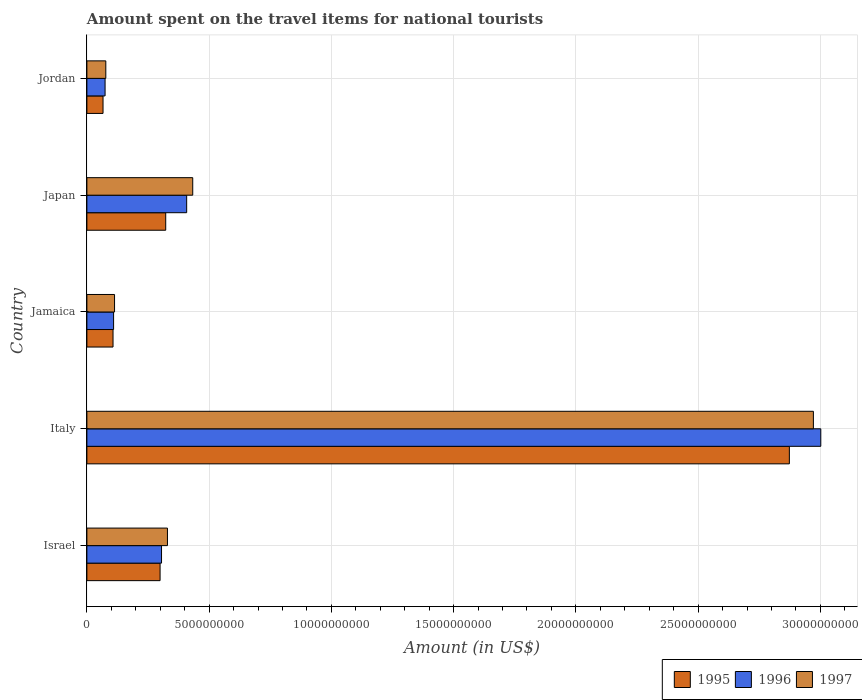How many different coloured bars are there?
Your answer should be very brief. 3. How many groups of bars are there?
Your answer should be compact. 5. Are the number of bars per tick equal to the number of legend labels?
Keep it short and to the point. Yes. Are the number of bars on each tick of the Y-axis equal?
Your answer should be very brief. Yes. How many bars are there on the 4th tick from the top?
Your answer should be very brief. 3. In how many cases, is the number of bars for a given country not equal to the number of legend labels?
Your answer should be very brief. 0. What is the amount spent on the travel items for national tourists in 1995 in Japan?
Provide a short and direct response. 3.22e+09. Across all countries, what is the maximum amount spent on the travel items for national tourists in 1995?
Offer a very short reply. 2.87e+1. Across all countries, what is the minimum amount spent on the travel items for national tourists in 1997?
Offer a very short reply. 7.74e+08. In which country was the amount spent on the travel items for national tourists in 1996 minimum?
Offer a very short reply. Jordan. What is the total amount spent on the travel items for national tourists in 1997 in the graph?
Ensure brevity in your answer.  3.92e+1. What is the difference between the amount spent on the travel items for national tourists in 1996 in Israel and that in Italy?
Your answer should be compact. -2.70e+1. What is the difference between the amount spent on the travel items for national tourists in 1997 in Italy and the amount spent on the travel items for national tourists in 1995 in Japan?
Your answer should be very brief. 2.65e+1. What is the average amount spent on the travel items for national tourists in 1997 per country?
Provide a succinct answer. 7.85e+09. What is the difference between the amount spent on the travel items for national tourists in 1997 and amount spent on the travel items for national tourists in 1996 in Japan?
Your answer should be compact. 2.48e+08. What is the ratio of the amount spent on the travel items for national tourists in 1996 in Jamaica to that in Japan?
Make the answer very short. 0.27. Is the difference between the amount spent on the travel items for national tourists in 1997 in Italy and Japan greater than the difference between the amount spent on the travel items for national tourists in 1996 in Italy and Japan?
Your answer should be compact. No. What is the difference between the highest and the second highest amount spent on the travel items for national tourists in 1995?
Ensure brevity in your answer.  2.55e+1. What is the difference between the highest and the lowest amount spent on the travel items for national tourists in 1996?
Offer a very short reply. 2.93e+1. In how many countries, is the amount spent on the travel items for national tourists in 1995 greater than the average amount spent on the travel items for national tourists in 1995 taken over all countries?
Make the answer very short. 1. Is the sum of the amount spent on the travel items for national tourists in 1996 in Israel and Jordan greater than the maximum amount spent on the travel items for national tourists in 1995 across all countries?
Give a very brief answer. No. What does the 1st bar from the top in Jamaica represents?
Your answer should be compact. 1997. How many bars are there?
Provide a succinct answer. 15. Are all the bars in the graph horizontal?
Offer a very short reply. Yes. How many countries are there in the graph?
Ensure brevity in your answer.  5. Does the graph contain any zero values?
Keep it short and to the point. No. Does the graph contain grids?
Your response must be concise. Yes. How are the legend labels stacked?
Your response must be concise. Horizontal. What is the title of the graph?
Offer a very short reply. Amount spent on the travel items for national tourists. Does "2006" appear as one of the legend labels in the graph?
Ensure brevity in your answer.  No. What is the label or title of the Y-axis?
Provide a short and direct response. Country. What is the Amount (in US$) in 1995 in Israel?
Your answer should be very brief. 2.99e+09. What is the Amount (in US$) of 1996 in Israel?
Ensure brevity in your answer.  3.05e+09. What is the Amount (in US$) in 1997 in Israel?
Ensure brevity in your answer.  3.30e+09. What is the Amount (in US$) in 1995 in Italy?
Ensure brevity in your answer.  2.87e+1. What is the Amount (in US$) of 1996 in Italy?
Provide a short and direct response. 3.00e+1. What is the Amount (in US$) in 1997 in Italy?
Keep it short and to the point. 2.97e+1. What is the Amount (in US$) of 1995 in Jamaica?
Your response must be concise. 1.07e+09. What is the Amount (in US$) in 1996 in Jamaica?
Provide a succinct answer. 1.09e+09. What is the Amount (in US$) in 1997 in Jamaica?
Keep it short and to the point. 1.13e+09. What is the Amount (in US$) in 1995 in Japan?
Your answer should be very brief. 3.22e+09. What is the Amount (in US$) of 1996 in Japan?
Make the answer very short. 4.08e+09. What is the Amount (in US$) in 1997 in Japan?
Make the answer very short. 4.33e+09. What is the Amount (in US$) of 1995 in Jordan?
Ensure brevity in your answer.  6.60e+08. What is the Amount (in US$) in 1996 in Jordan?
Your answer should be compact. 7.44e+08. What is the Amount (in US$) of 1997 in Jordan?
Your answer should be very brief. 7.74e+08. Across all countries, what is the maximum Amount (in US$) of 1995?
Your response must be concise. 2.87e+1. Across all countries, what is the maximum Amount (in US$) in 1996?
Provide a short and direct response. 3.00e+1. Across all countries, what is the maximum Amount (in US$) of 1997?
Your answer should be very brief. 2.97e+1. Across all countries, what is the minimum Amount (in US$) of 1995?
Provide a succinct answer. 6.60e+08. Across all countries, what is the minimum Amount (in US$) of 1996?
Your answer should be very brief. 7.44e+08. Across all countries, what is the minimum Amount (in US$) in 1997?
Offer a terse response. 7.74e+08. What is the total Amount (in US$) of 1995 in the graph?
Offer a terse response. 3.67e+1. What is the total Amount (in US$) of 1996 in the graph?
Your answer should be very brief. 3.90e+1. What is the total Amount (in US$) in 1997 in the graph?
Ensure brevity in your answer.  3.92e+1. What is the difference between the Amount (in US$) of 1995 in Israel and that in Italy?
Make the answer very short. -2.57e+1. What is the difference between the Amount (in US$) of 1996 in Israel and that in Italy?
Your answer should be compact. -2.70e+1. What is the difference between the Amount (in US$) of 1997 in Israel and that in Italy?
Offer a very short reply. -2.64e+1. What is the difference between the Amount (in US$) of 1995 in Israel and that in Jamaica?
Your answer should be very brief. 1.92e+09. What is the difference between the Amount (in US$) of 1996 in Israel and that in Jamaica?
Offer a very short reply. 1.96e+09. What is the difference between the Amount (in US$) of 1997 in Israel and that in Jamaica?
Ensure brevity in your answer.  2.16e+09. What is the difference between the Amount (in US$) of 1995 in Israel and that in Japan?
Offer a very short reply. -2.31e+08. What is the difference between the Amount (in US$) in 1996 in Israel and that in Japan?
Provide a short and direct response. -1.03e+09. What is the difference between the Amount (in US$) of 1997 in Israel and that in Japan?
Keep it short and to the point. -1.03e+09. What is the difference between the Amount (in US$) of 1995 in Israel and that in Jordan?
Keep it short and to the point. 2.33e+09. What is the difference between the Amount (in US$) in 1996 in Israel and that in Jordan?
Ensure brevity in your answer.  2.31e+09. What is the difference between the Amount (in US$) in 1997 in Israel and that in Jordan?
Your answer should be very brief. 2.52e+09. What is the difference between the Amount (in US$) in 1995 in Italy and that in Jamaica?
Give a very brief answer. 2.77e+1. What is the difference between the Amount (in US$) in 1996 in Italy and that in Jamaica?
Ensure brevity in your answer.  2.89e+1. What is the difference between the Amount (in US$) in 1997 in Italy and that in Jamaica?
Provide a succinct answer. 2.86e+1. What is the difference between the Amount (in US$) of 1995 in Italy and that in Japan?
Keep it short and to the point. 2.55e+1. What is the difference between the Amount (in US$) in 1996 in Italy and that in Japan?
Provide a succinct answer. 2.59e+1. What is the difference between the Amount (in US$) of 1997 in Italy and that in Japan?
Your answer should be compact. 2.54e+1. What is the difference between the Amount (in US$) in 1995 in Italy and that in Jordan?
Ensure brevity in your answer.  2.81e+1. What is the difference between the Amount (in US$) in 1996 in Italy and that in Jordan?
Make the answer very short. 2.93e+1. What is the difference between the Amount (in US$) of 1997 in Italy and that in Jordan?
Your answer should be compact. 2.89e+1. What is the difference between the Amount (in US$) in 1995 in Jamaica and that in Japan?
Give a very brief answer. -2.16e+09. What is the difference between the Amount (in US$) in 1996 in Jamaica and that in Japan?
Offer a very short reply. -2.99e+09. What is the difference between the Amount (in US$) in 1997 in Jamaica and that in Japan?
Give a very brief answer. -3.20e+09. What is the difference between the Amount (in US$) of 1995 in Jamaica and that in Jordan?
Make the answer very short. 4.09e+08. What is the difference between the Amount (in US$) of 1996 in Jamaica and that in Jordan?
Provide a short and direct response. 3.48e+08. What is the difference between the Amount (in US$) of 1997 in Jamaica and that in Jordan?
Give a very brief answer. 3.57e+08. What is the difference between the Amount (in US$) of 1995 in Japan and that in Jordan?
Make the answer very short. 2.56e+09. What is the difference between the Amount (in US$) of 1996 in Japan and that in Jordan?
Offer a very short reply. 3.34e+09. What is the difference between the Amount (in US$) of 1997 in Japan and that in Jordan?
Your answer should be very brief. 3.56e+09. What is the difference between the Amount (in US$) of 1995 in Israel and the Amount (in US$) of 1996 in Italy?
Make the answer very short. -2.70e+1. What is the difference between the Amount (in US$) of 1995 in Israel and the Amount (in US$) of 1997 in Italy?
Provide a succinct answer. -2.67e+1. What is the difference between the Amount (in US$) of 1996 in Israel and the Amount (in US$) of 1997 in Italy?
Make the answer very short. -2.67e+1. What is the difference between the Amount (in US$) of 1995 in Israel and the Amount (in US$) of 1996 in Jamaica?
Ensure brevity in your answer.  1.90e+09. What is the difference between the Amount (in US$) in 1995 in Israel and the Amount (in US$) in 1997 in Jamaica?
Keep it short and to the point. 1.86e+09. What is the difference between the Amount (in US$) in 1996 in Israel and the Amount (in US$) in 1997 in Jamaica?
Your answer should be very brief. 1.92e+09. What is the difference between the Amount (in US$) of 1995 in Israel and the Amount (in US$) of 1996 in Japan?
Your answer should be compact. -1.09e+09. What is the difference between the Amount (in US$) in 1995 in Israel and the Amount (in US$) in 1997 in Japan?
Your answer should be very brief. -1.34e+09. What is the difference between the Amount (in US$) of 1996 in Israel and the Amount (in US$) of 1997 in Japan?
Give a very brief answer. -1.28e+09. What is the difference between the Amount (in US$) in 1995 in Israel and the Amount (in US$) in 1996 in Jordan?
Give a very brief answer. 2.25e+09. What is the difference between the Amount (in US$) of 1995 in Israel and the Amount (in US$) of 1997 in Jordan?
Your response must be concise. 2.22e+09. What is the difference between the Amount (in US$) of 1996 in Israel and the Amount (in US$) of 1997 in Jordan?
Your response must be concise. 2.28e+09. What is the difference between the Amount (in US$) of 1995 in Italy and the Amount (in US$) of 1996 in Jamaica?
Offer a very short reply. 2.76e+1. What is the difference between the Amount (in US$) of 1995 in Italy and the Amount (in US$) of 1997 in Jamaica?
Provide a short and direct response. 2.76e+1. What is the difference between the Amount (in US$) of 1996 in Italy and the Amount (in US$) of 1997 in Jamaica?
Your answer should be very brief. 2.89e+1. What is the difference between the Amount (in US$) of 1995 in Italy and the Amount (in US$) of 1996 in Japan?
Your answer should be compact. 2.46e+1. What is the difference between the Amount (in US$) in 1995 in Italy and the Amount (in US$) in 1997 in Japan?
Your answer should be compact. 2.44e+1. What is the difference between the Amount (in US$) in 1996 in Italy and the Amount (in US$) in 1997 in Japan?
Your answer should be compact. 2.57e+1. What is the difference between the Amount (in US$) in 1995 in Italy and the Amount (in US$) in 1996 in Jordan?
Ensure brevity in your answer.  2.80e+1. What is the difference between the Amount (in US$) in 1995 in Italy and the Amount (in US$) in 1997 in Jordan?
Your answer should be compact. 2.80e+1. What is the difference between the Amount (in US$) in 1996 in Italy and the Amount (in US$) in 1997 in Jordan?
Your answer should be compact. 2.92e+1. What is the difference between the Amount (in US$) in 1995 in Jamaica and the Amount (in US$) in 1996 in Japan?
Your answer should be very brief. -3.01e+09. What is the difference between the Amount (in US$) in 1995 in Jamaica and the Amount (in US$) in 1997 in Japan?
Keep it short and to the point. -3.26e+09. What is the difference between the Amount (in US$) in 1996 in Jamaica and the Amount (in US$) in 1997 in Japan?
Make the answer very short. -3.24e+09. What is the difference between the Amount (in US$) of 1995 in Jamaica and the Amount (in US$) of 1996 in Jordan?
Ensure brevity in your answer.  3.25e+08. What is the difference between the Amount (in US$) of 1995 in Jamaica and the Amount (in US$) of 1997 in Jordan?
Offer a very short reply. 2.95e+08. What is the difference between the Amount (in US$) in 1996 in Jamaica and the Amount (in US$) in 1997 in Jordan?
Ensure brevity in your answer.  3.18e+08. What is the difference between the Amount (in US$) of 1995 in Japan and the Amount (in US$) of 1996 in Jordan?
Provide a short and direct response. 2.48e+09. What is the difference between the Amount (in US$) of 1995 in Japan and the Amount (in US$) of 1997 in Jordan?
Provide a succinct answer. 2.45e+09. What is the difference between the Amount (in US$) in 1996 in Japan and the Amount (in US$) in 1997 in Jordan?
Make the answer very short. 3.31e+09. What is the average Amount (in US$) in 1995 per country?
Offer a very short reply. 7.34e+09. What is the average Amount (in US$) of 1996 per country?
Provide a succinct answer. 7.80e+09. What is the average Amount (in US$) in 1997 per country?
Give a very brief answer. 7.85e+09. What is the difference between the Amount (in US$) in 1995 and Amount (in US$) in 1996 in Israel?
Your response must be concise. -6.00e+07. What is the difference between the Amount (in US$) of 1995 and Amount (in US$) of 1997 in Israel?
Keep it short and to the point. -3.02e+08. What is the difference between the Amount (in US$) of 1996 and Amount (in US$) of 1997 in Israel?
Your answer should be very brief. -2.42e+08. What is the difference between the Amount (in US$) of 1995 and Amount (in US$) of 1996 in Italy?
Your response must be concise. -1.29e+09. What is the difference between the Amount (in US$) of 1995 and Amount (in US$) of 1997 in Italy?
Your response must be concise. -9.83e+08. What is the difference between the Amount (in US$) in 1996 and Amount (in US$) in 1997 in Italy?
Provide a succinct answer. 3.03e+08. What is the difference between the Amount (in US$) in 1995 and Amount (in US$) in 1996 in Jamaica?
Provide a succinct answer. -2.30e+07. What is the difference between the Amount (in US$) in 1995 and Amount (in US$) in 1997 in Jamaica?
Provide a succinct answer. -6.20e+07. What is the difference between the Amount (in US$) of 1996 and Amount (in US$) of 1997 in Jamaica?
Give a very brief answer. -3.90e+07. What is the difference between the Amount (in US$) in 1995 and Amount (in US$) in 1996 in Japan?
Provide a short and direct response. -8.57e+08. What is the difference between the Amount (in US$) of 1995 and Amount (in US$) of 1997 in Japan?
Ensure brevity in your answer.  -1.10e+09. What is the difference between the Amount (in US$) of 1996 and Amount (in US$) of 1997 in Japan?
Ensure brevity in your answer.  -2.48e+08. What is the difference between the Amount (in US$) in 1995 and Amount (in US$) in 1996 in Jordan?
Your answer should be very brief. -8.40e+07. What is the difference between the Amount (in US$) of 1995 and Amount (in US$) of 1997 in Jordan?
Make the answer very short. -1.14e+08. What is the difference between the Amount (in US$) of 1996 and Amount (in US$) of 1997 in Jordan?
Your answer should be very brief. -3.00e+07. What is the ratio of the Amount (in US$) in 1995 in Israel to that in Italy?
Ensure brevity in your answer.  0.1. What is the ratio of the Amount (in US$) of 1996 in Israel to that in Italy?
Give a very brief answer. 0.1. What is the ratio of the Amount (in US$) in 1997 in Israel to that in Italy?
Keep it short and to the point. 0.11. What is the ratio of the Amount (in US$) in 1995 in Israel to that in Jamaica?
Make the answer very short. 2.8. What is the ratio of the Amount (in US$) of 1996 in Israel to that in Jamaica?
Give a very brief answer. 2.8. What is the ratio of the Amount (in US$) in 1997 in Israel to that in Jamaica?
Offer a terse response. 2.91. What is the ratio of the Amount (in US$) of 1995 in Israel to that in Japan?
Keep it short and to the point. 0.93. What is the ratio of the Amount (in US$) in 1996 in Israel to that in Japan?
Offer a very short reply. 0.75. What is the ratio of the Amount (in US$) in 1997 in Israel to that in Japan?
Offer a terse response. 0.76. What is the ratio of the Amount (in US$) in 1995 in Israel to that in Jordan?
Give a very brief answer. 4.53. What is the ratio of the Amount (in US$) in 1996 in Israel to that in Jordan?
Offer a very short reply. 4.1. What is the ratio of the Amount (in US$) in 1997 in Israel to that in Jordan?
Provide a succinct answer. 4.26. What is the ratio of the Amount (in US$) of 1995 in Italy to that in Jamaica?
Your answer should be very brief. 26.88. What is the ratio of the Amount (in US$) in 1996 in Italy to that in Jamaica?
Give a very brief answer. 27.49. What is the ratio of the Amount (in US$) in 1997 in Italy to that in Jamaica?
Offer a very short reply. 26.27. What is the ratio of the Amount (in US$) in 1995 in Italy to that in Japan?
Provide a succinct answer. 8.91. What is the ratio of the Amount (in US$) in 1996 in Italy to that in Japan?
Provide a succinct answer. 7.36. What is the ratio of the Amount (in US$) in 1997 in Italy to that in Japan?
Your answer should be compact. 6.86. What is the ratio of the Amount (in US$) of 1995 in Italy to that in Jordan?
Your answer should be very brief. 43.53. What is the ratio of the Amount (in US$) of 1996 in Italy to that in Jordan?
Give a very brief answer. 40.35. What is the ratio of the Amount (in US$) in 1997 in Italy to that in Jordan?
Your answer should be very brief. 38.39. What is the ratio of the Amount (in US$) of 1995 in Jamaica to that in Japan?
Provide a short and direct response. 0.33. What is the ratio of the Amount (in US$) in 1996 in Jamaica to that in Japan?
Offer a terse response. 0.27. What is the ratio of the Amount (in US$) of 1997 in Jamaica to that in Japan?
Offer a terse response. 0.26. What is the ratio of the Amount (in US$) of 1995 in Jamaica to that in Jordan?
Your answer should be compact. 1.62. What is the ratio of the Amount (in US$) in 1996 in Jamaica to that in Jordan?
Keep it short and to the point. 1.47. What is the ratio of the Amount (in US$) of 1997 in Jamaica to that in Jordan?
Provide a succinct answer. 1.46. What is the ratio of the Amount (in US$) in 1995 in Japan to that in Jordan?
Provide a short and direct response. 4.88. What is the ratio of the Amount (in US$) of 1996 in Japan to that in Jordan?
Offer a very short reply. 5.49. What is the ratio of the Amount (in US$) of 1997 in Japan to that in Jordan?
Provide a short and direct response. 5.59. What is the difference between the highest and the second highest Amount (in US$) in 1995?
Offer a very short reply. 2.55e+1. What is the difference between the highest and the second highest Amount (in US$) of 1996?
Your answer should be very brief. 2.59e+1. What is the difference between the highest and the second highest Amount (in US$) in 1997?
Keep it short and to the point. 2.54e+1. What is the difference between the highest and the lowest Amount (in US$) of 1995?
Offer a terse response. 2.81e+1. What is the difference between the highest and the lowest Amount (in US$) of 1996?
Provide a succinct answer. 2.93e+1. What is the difference between the highest and the lowest Amount (in US$) in 1997?
Offer a terse response. 2.89e+1. 